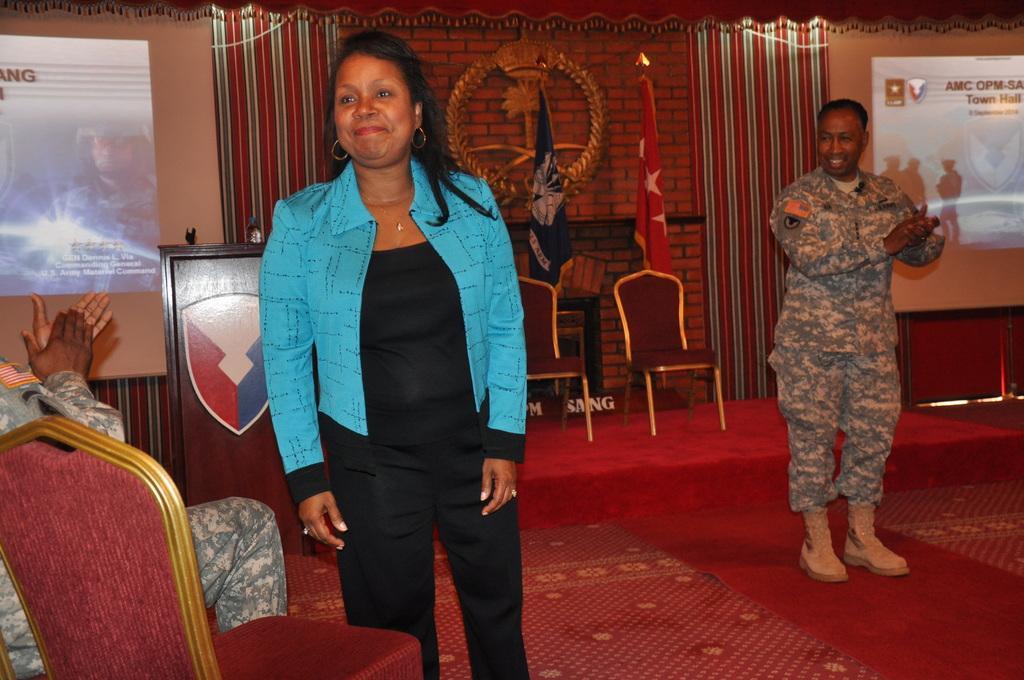How would you summarize this image in a sentence or two? In this image I can see a woman standing, wearing a blue coat and a black dress. There is a person sitting on the left. A person is standing, wearing an army uniform. There are chairs on the right and there are flags and projector displays at the back. 